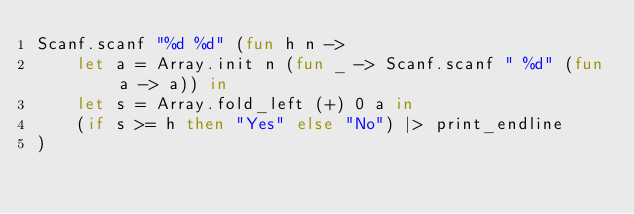<code> <loc_0><loc_0><loc_500><loc_500><_OCaml_>Scanf.scanf "%d %d" (fun h n ->
    let a = Array.init n (fun _ -> Scanf.scanf " %d" (fun a -> a)) in
    let s = Array.fold_left (+) 0 a in
    (if s >= h then "Yes" else "No") |> print_endline
)</code> 